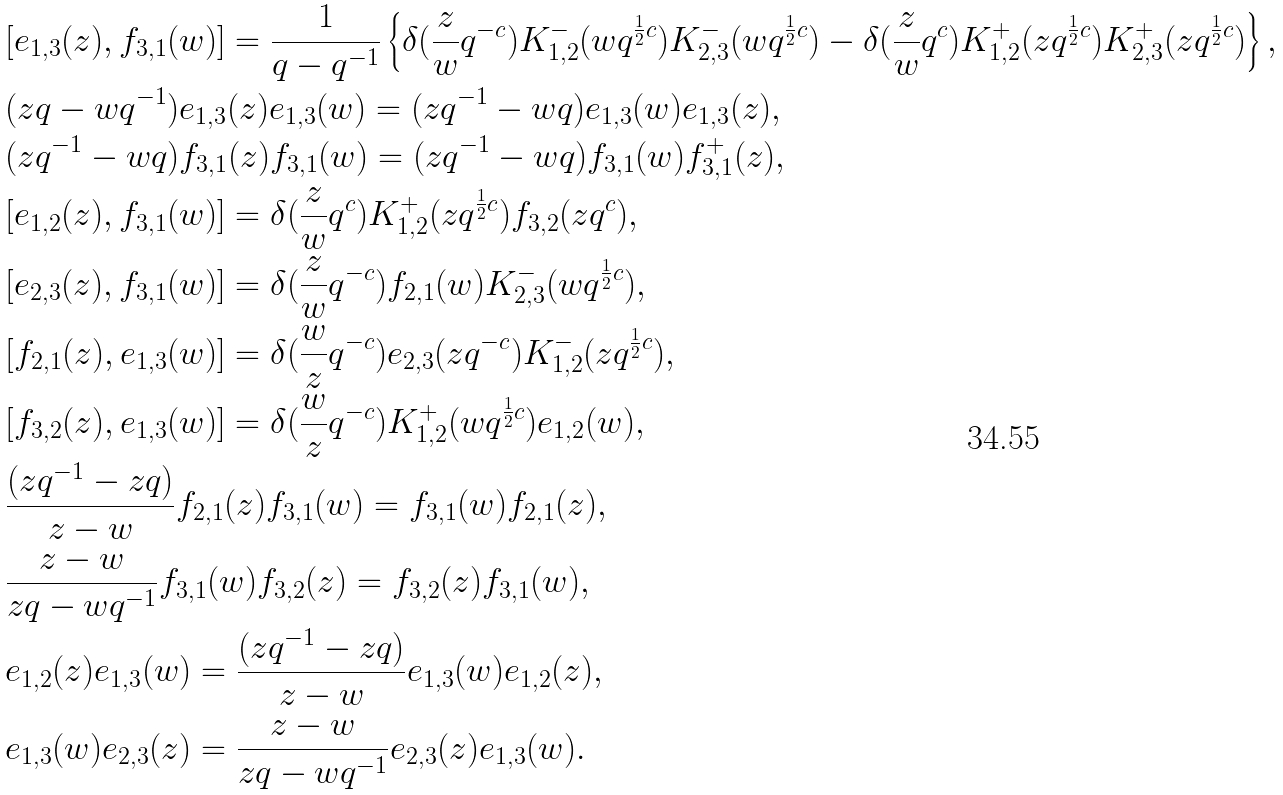Convert formula to latex. <formula><loc_0><loc_0><loc_500><loc_500>& [ e _ { 1 , 3 } ( z ) , f _ { 3 , 1 } ( w ) ] = \frac { 1 } { q - q ^ { - 1 } } \left \{ \delta ( \frac { z } { w } q ^ { - c } ) K ^ { - } _ { 1 , 2 } ( w q ^ { \frac { 1 } { 2 } c } ) K ^ { - } _ { 2 , 3 } ( w q ^ { \frac { 1 } { 2 } c } ) - \delta ( \frac { z } { w } q ^ { c } ) K ^ { + } _ { 1 , 2 } ( z q ^ { \frac { 1 } { 2 } c } ) K ^ { + } _ { 2 , 3 } ( z q ^ { \frac { 1 } { 2 } c } ) \right \} , \\ & ( z q - w q ^ { - 1 } ) e _ { 1 , 3 } ( z ) e _ { 1 , 3 } ( w ) = ( z q ^ { - 1 } - w q ) e _ { 1 , 3 } ( w ) e _ { 1 , 3 } ( z ) , \\ & ( z q ^ { - 1 } - w q ) f _ { 3 , 1 } ( z ) f _ { 3 , 1 } ( w ) = ( z q ^ { - 1 } - w q ) f _ { 3 , 1 } ( w ) f _ { 3 , 1 } ^ { + } ( z ) , \\ & [ e _ { 1 , 2 } ( z ) , f _ { 3 , 1 } ( w ) ] = \delta ( \frac { z } { w } q ^ { c } ) K ^ { + } _ { 1 , 2 } ( z q ^ { \frac { 1 } { 2 } c } ) f _ { 3 , 2 } ( z q ^ { c } ) , \\ & [ e _ { 2 , 3 } ( z ) , f _ { 3 , 1 } ( w ) ] = \delta ( \frac { z } { w } q ^ { - c } ) f _ { 2 , 1 } ( w ) K ^ { - } _ { 2 , 3 } ( w q ^ { \frac { 1 } { 2 } c } ) , \\ & [ f _ { 2 , 1 } ( z ) , e _ { 1 , 3 } ( w ) ] = \delta ( \frac { w } { z } q ^ { - c } ) e _ { 2 , 3 } ( z q ^ { - c } ) K ^ { - } _ { 1 , 2 } ( z q ^ { \frac { 1 } { 2 } c } ) , \\ & [ f _ { 3 , 2 } ( z ) , e _ { 1 , 3 } ( w ) ] = \delta ( \frac { w } { z } q ^ { - c } ) K ^ { + } _ { 1 , 2 } ( w q ^ { \frac { 1 } { 2 } c } ) e _ { 1 , 2 } ( w ) , \\ & \frac { ( z q ^ { - 1 } - z q ) } { z - w } f _ { 2 , 1 } ( z ) f _ { 3 , 1 } ( w ) = f _ { 3 , 1 } ( w ) f _ { 2 , 1 } ( z ) , \\ & \frac { z - w } { z q - w q ^ { - 1 } } f _ { 3 , 1 } ( w ) f _ { 3 , 2 } ( z ) = f _ { 3 , 2 } ( z ) f _ { 3 , 1 } ( w ) , \\ & e _ { 1 , 2 } ( z ) e _ { 1 , 3 } ( w ) = \frac { ( z q ^ { - 1 } - z q ) } { z - w } e _ { 1 , 3 } ( w ) e _ { 1 , 2 } ( z ) , \\ & e _ { 1 , 3 } ( w ) e _ { 2 , 3 } ( z ) = \frac { z - w } { z q - w q ^ { - 1 } } e _ { 2 , 3 } ( z ) e _ { 1 , 3 } ( w ) .</formula> 